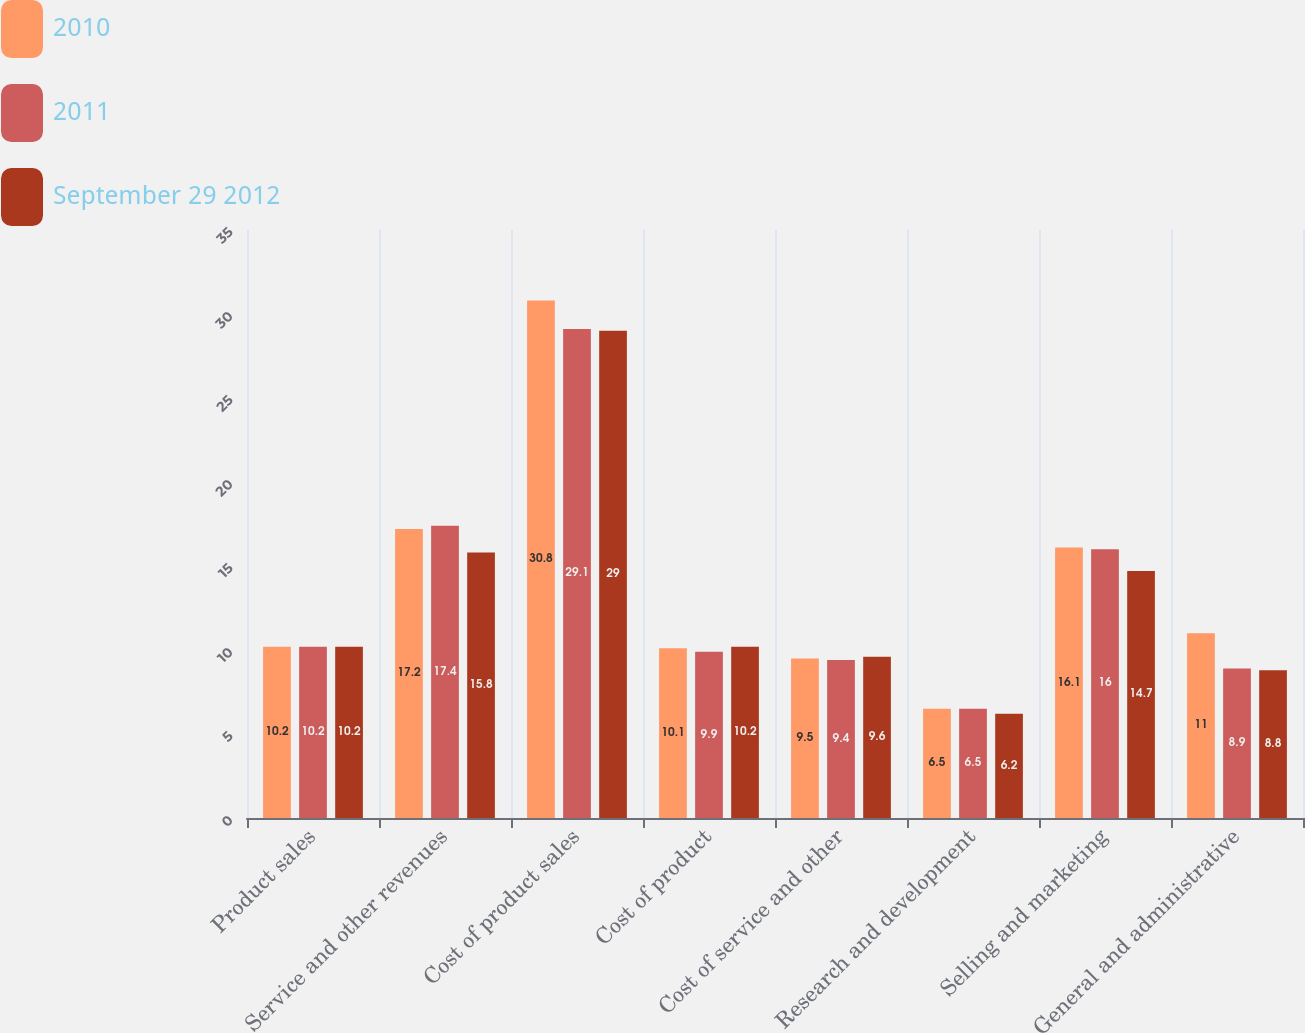Convert chart to OTSL. <chart><loc_0><loc_0><loc_500><loc_500><stacked_bar_chart><ecel><fcel>Product sales<fcel>Service and other revenues<fcel>Cost of product sales<fcel>Cost of product<fcel>Cost of service and other<fcel>Research and development<fcel>Selling and marketing<fcel>General and administrative<nl><fcel>2010<fcel>10.2<fcel>17.2<fcel>30.8<fcel>10.1<fcel>9.5<fcel>6.5<fcel>16.1<fcel>11<nl><fcel>2011<fcel>10.2<fcel>17.4<fcel>29.1<fcel>9.9<fcel>9.4<fcel>6.5<fcel>16<fcel>8.9<nl><fcel>September 29 2012<fcel>10.2<fcel>15.8<fcel>29<fcel>10.2<fcel>9.6<fcel>6.2<fcel>14.7<fcel>8.8<nl></chart> 